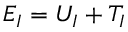<formula> <loc_0><loc_0><loc_500><loc_500>E _ { I } = U _ { I } + T _ { I }</formula> 